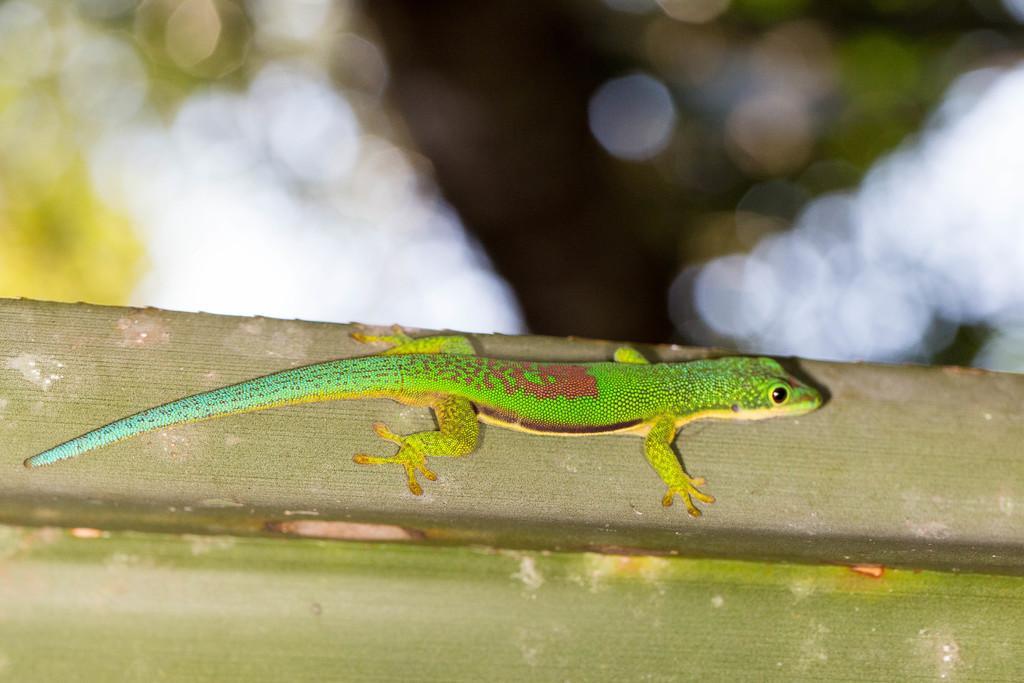Please provide a concise description of this image. Here in this picture we can see a green anole present on a wooden post over there. 